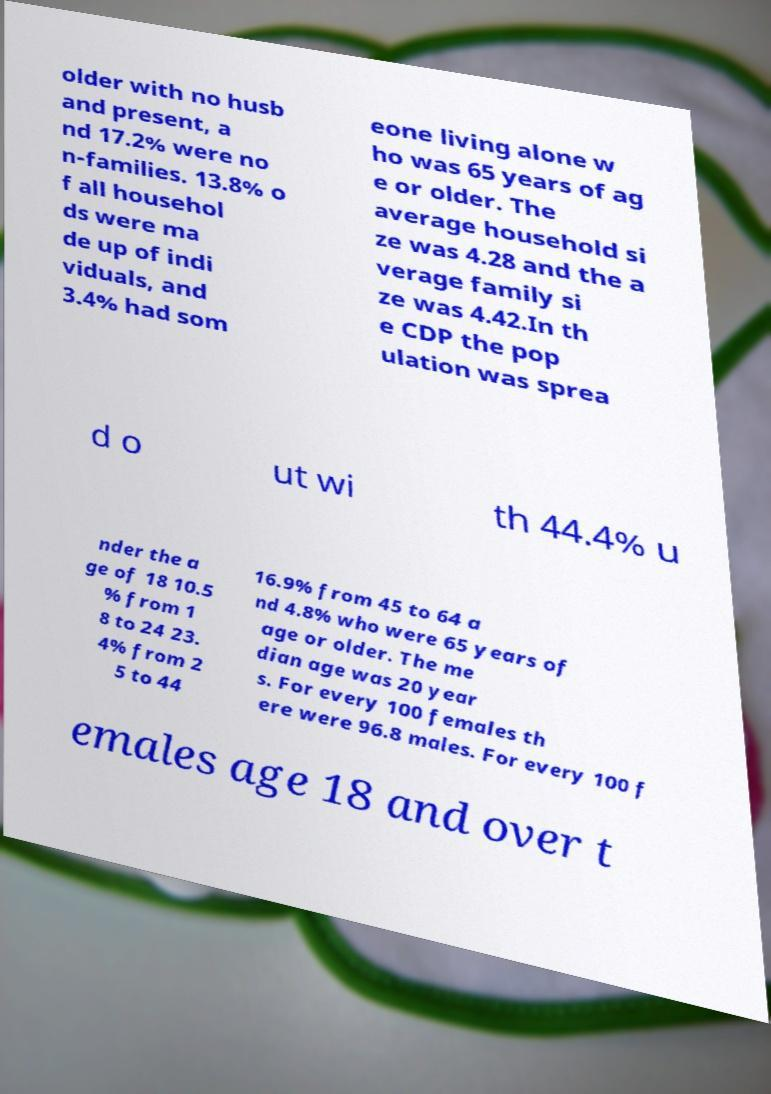What messages or text are displayed in this image? I need them in a readable, typed format. older with no husb and present, a nd 17.2% were no n-families. 13.8% o f all househol ds were ma de up of indi viduals, and 3.4% had som eone living alone w ho was 65 years of ag e or older. The average household si ze was 4.28 and the a verage family si ze was 4.42.In th e CDP the pop ulation was sprea d o ut wi th 44.4% u nder the a ge of 18 10.5 % from 1 8 to 24 23. 4% from 2 5 to 44 16.9% from 45 to 64 a nd 4.8% who were 65 years of age or older. The me dian age was 20 year s. For every 100 females th ere were 96.8 males. For every 100 f emales age 18 and over t 